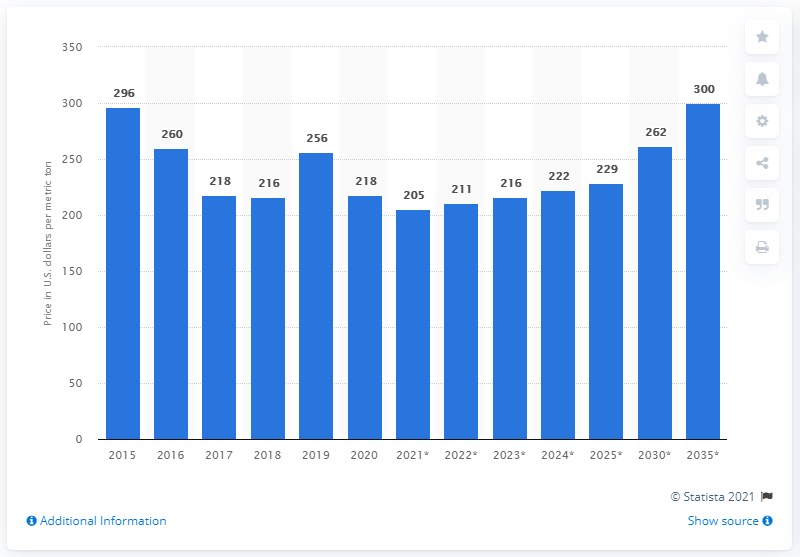Highlight a few significant elements in this photo. It is expected that the price of potassium chloride will increase by 2035. In 2020, the cost of potassium chloride per metric ton was $218. 